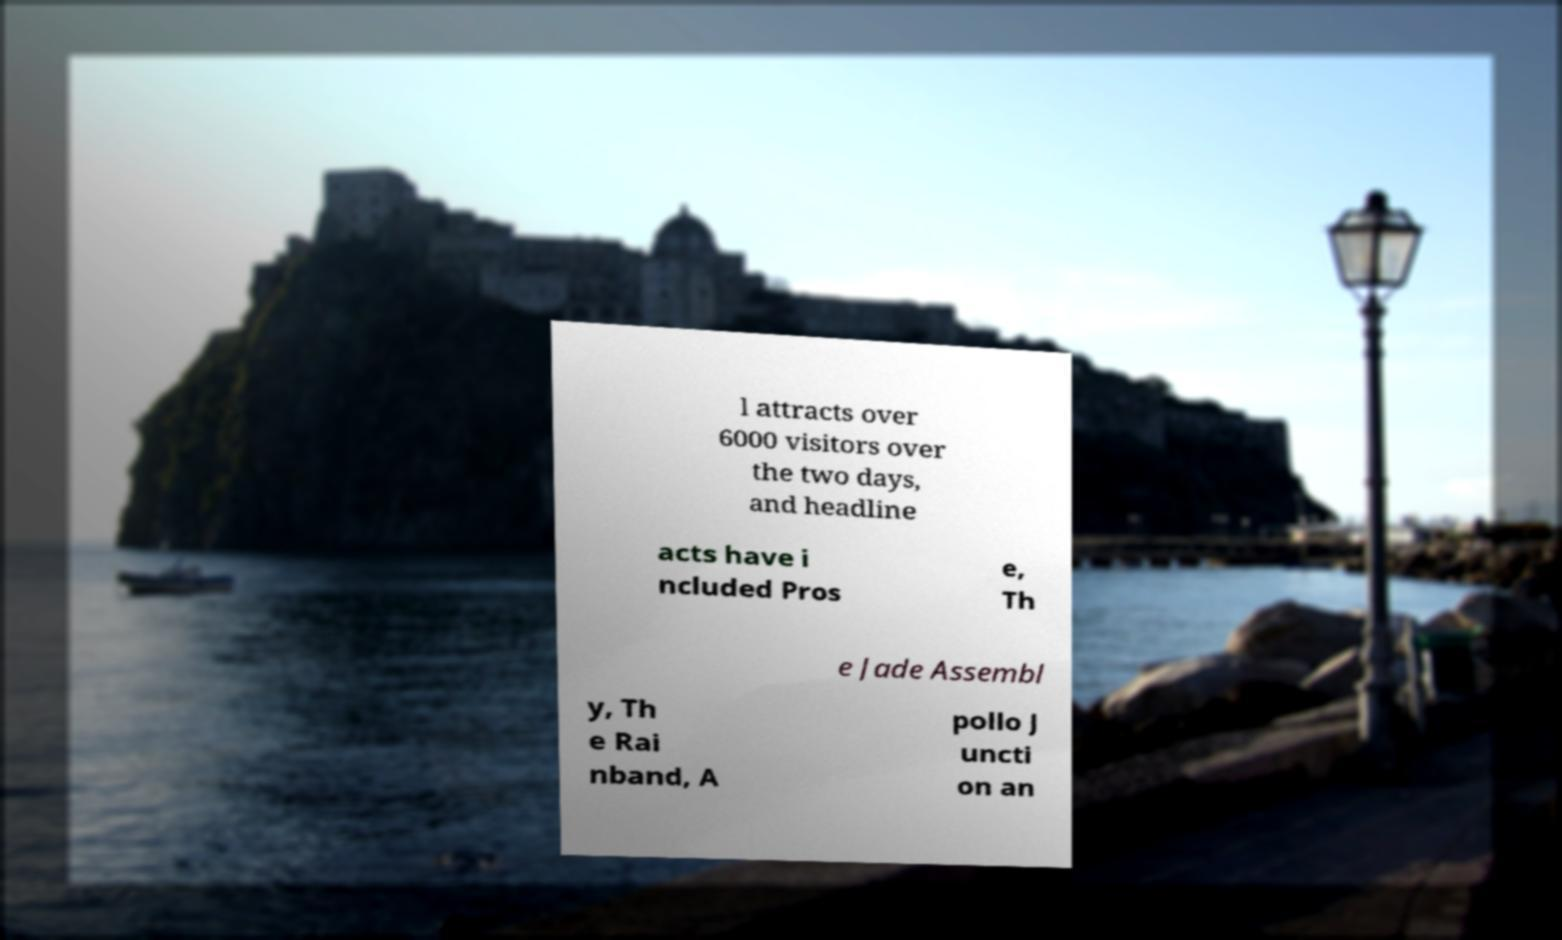Can you read and provide the text displayed in the image?This photo seems to have some interesting text. Can you extract and type it out for me? l attracts over 6000 visitors over the two days, and headline acts have i ncluded Pros e, Th e Jade Assembl y, Th e Rai nband, A pollo J uncti on an 